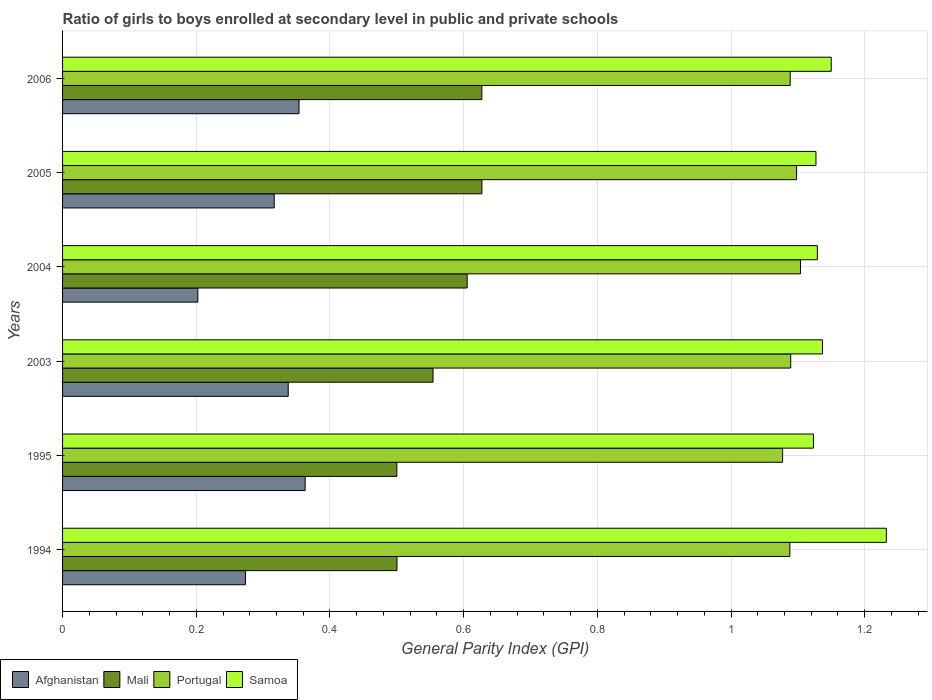How many groups of bars are there?
Your answer should be very brief. 6. Are the number of bars per tick equal to the number of legend labels?
Offer a very short reply. Yes. Are the number of bars on each tick of the Y-axis equal?
Offer a very short reply. Yes. How many bars are there on the 5th tick from the bottom?
Ensure brevity in your answer.  4. What is the general parity index in Mali in 2004?
Your answer should be compact. 0.61. Across all years, what is the maximum general parity index in Portugal?
Offer a very short reply. 1.1. Across all years, what is the minimum general parity index in Mali?
Provide a short and direct response. 0.5. What is the total general parity index in Afghanistan in the graph?
Provide a short and direct response. 1.85. What is the difference between the general parity index in Portugal in 1994 and that in 2003?
Provide a succinct answer. -0. What is the difference between the general parity index in Samoa in 2006 and the general parity index in Portugal in 1995?
Ensure brevity in your answer.  0.07. What is the average general parity index in Samoa per year?
Ensure brevity in your answer.  1.15. In the year 1995, what is the difference between the general parity index in Samoa and general parity index in Afghanistan?
Your answer should be very brief. 0.76. In how many years, is the general parity index in Mali greater than 0.8 ?
Offer a terse response. 0. What is the ratio of the general parity index in Afghanistan in 1995 to that in 2005?
Make the answer very short. 1.15. Is the general parity index in Samoa in 1995 less than that in 2003?
Give a very brief answer. Yes. Is the difference between the general parity index in Samoa in 2003 and 2005 greater than the difference between the general parity index in Afghanistan in 2003 and 2005?
Provide a succinct answer. No. What is the difference between the highest and the second highest general parity index in Portugal?
Give a very brief answer. 0.01. What is the difference between the highest and the lowest general parity index in Afghanistan?
Provide a short and direct response. 0.16. In how many years, is the general parity index in Samoa greater than the average general parity index in Samoa taken over all years?
Provide a short and direct response. 2. Is the sum of the general parity index in Portugal in 2005 and 2006 greater than the maximum general parity index in Mali across all years?
Your answer should be compact. Yes. What does the 3rd bar from the top in 2005 represents?
Give a very brief answer. Mali. What does the 2nd bar from the bottom in 1995 represents?
Your response must be concise. Mali. Is it the case that in every year, the sum of the general parity index in Mali and general parity index in Afghanistan is greater than the general parity index in Samoa?
Offer a terse response. No. How many bars are there?
Offer a very short reply. 24. Are all the bars in the graph horizontal?
Ensure brevity in your answer.  Yes. How many years are there in the graph?
Provide a succinct answer. 6. What is the difference between two consecutive major ticks on the X-axis?
Your answer should be compact. 0.2. Where does the legend appear in the graph?
Ensure brevity in your answer.  Bottom left. How are the legend labels stacked?
Make the answer very short. Horizontal. What is the title of the graph?
Give a very brief answer. Ratio of girls to boys enrolled at secondary level in public and private schools. Does "Mauritania" appear as one of the legend labels in the graph?
Offer a very short reply. No. What is the label or title of the X-axis?
Offer a terse response. General Parity Index (GPI). What is the General Parity Index (GPI) in Afghanistan in 1994?
Keep it short and to the point. 0.27. What is the General Parity Index (GPI) in Mali in 1994?
Ensure brevity in your answer.  0.5. What is the General Parity Index (GPI) of Portugal in 1994?
Your answer should be compact. 1.09. What is the General Parity Index (GPI) in Samoa in 1994?
Offer a terse response. 1.23. What is the General Parity Index (GPI) in Afghanistan in 1995?
Keep it short and to the point. 0.36. What is the General Parity Index (GPI) of Mali in 1995?
Give a very brief answer. 0.5. What is the General Parity Index (GPI) in Portugal in 1995?
Provide a short and direct response. 1.08. What is the General Parity Index (GPI) in Samoa in 1995?
Provide a short and direct response. 1.12. What is the General Parity Index (GPI) of Afghanistan in 2003?
Ensure brevity in your answer.  0.34. What is the General Parity Index (GPI) in Mali in 2003?
Provide a succinct answer. 0.55. What is the General Parity Index (GPI) of Portugal in 2003?
Give a very brief answer. 1.09. What is the General Parity Index (GPI) of Samoa in 2003?
Provide a succinct answer. 1.14. What is the General Parity Index (GPI) in Afghanistan in 2004?
Your answer should be very brief. 0.2. What is the General Parity Index (GPI) of Mali in 2004?
Offer a terse response. 0.61. What is the General Parity Index (GPI) in Portugal in 2004?
Offer a very short reply. 1.1. What is the General Parity Index (GPI) of Samoa in 2004?
Make the answer very short. 1.13. What is the General Parity Index (GPI) of Afghanistan in 2005?
Give a very brief answer. 0.32. What is the General Parity Index (GPI) of Mali in 2005?
Provide a short and direct response. 0.63. What is the General Parity Index (GPI) of Portugal in 2005?
Make the answer very short. 1.1. What is the General Parity Index (GPI) in Samoa in 2005?
Offer a terse response. 1.13. What is the General Parity Index (GPI) in Afghanistan in 2006?
Give a very brief answer. 0.35. What is the General Parity Index (GPI) of Mali in 2006?
Your response must be concise. 0.63. What is the General Parity Index (GPI) in Portugal in 2006?
Your response must be concise. 1.09. What is the General Parity Index (GPI) of Samoa in 2006?
Your answer should be compact. 1.15. Across all years, what is the maximum General Parity Index (GPI) in Afghanistan?
Ensure brevity in your answer.  0.36. Across all years, what is the maximum General Parity Index (GPI) of Mali?
Offer a terse response. 0.63. Across all years, what is the maximum General Parity Index (GPI) in Portugal?
Offer a terse response. 1.1. Across all years, what is the maximum General Parity Index (GPI) in Samoa?
Ensure brevity in your answer.  1.23. Across all years, what is the minimum General Parity Index (GPI) of Afghanistan?
Your answer should be very brief. 0.2. Across all years, what is the minimum General Parity Index (GPI) in Mali?
Your response must be concise. 0.5. Across all years, what is the minimum General Parity Index (GPI) in Portugal?
Provide a succinct answer. 1.08. Across all years, what is the minimum General Parity Index (GPI) in Samoa?
Provide a short and direct response. 1.12. What is the total General Parity Index (GPI) in Afghanistan in the graph?
Your answer should be very brief. 1.85. What is the total General Parity Index (GPI) of Mali in the graph?
Offer a very short reply. 3.41. What is the total General Parity Index (GPI) in Portugal in the graph?
Offer a very short reply. 6.55. What is the total General Parity Index (GPI) of Samoa in the graph?
Your answer should be compact. 6.9. What is the difference between the General Parity Index (GPI) in Afghanistan in 1994 and that in 1995?
Your response must be concise. -0.09. What is the difference between the General Parity Index (GPI) in Portugal in 1994 and that in 1995?
Your answer should be compact. 0.01. What is the difference between the General Parity Index (GPI) in Samoa in 1994 and that in 1995?
Your answer should be compact. 0.11. What is the difference between the General Parity Index (GPI) of Afghanistan in 1994 and that in 2003?
Your answer should be very brief. -0.06. What is the difference between the General Parity Index (GPI) in Mali in 1994 and that in 2003?
Your answer should be very brief. -0.05. What is the difference between the General Parity Index (GPI) in Portugal in 1994 and that in 2003?
Your answer should be compact. -0. What is the difference between the General Parity Index (GPI) of Samoa in 1994 and that in 2003?
Make the answer very short. 0.1. What is the difference between the General Parity Index (GPI) in Afghanistan in 1994 and that in 2004?
Make the answer very short. 0.07. What is the difference between the General Parity Index (GPI) of Mali in 1994 and that in 2004?
Your response must be concise. -0.1. What is the difference between the General Parity Index (GPI) in Portugal in 1994 and that in 2004?
Offer a very short reply. -0.02. What is the difference between the General Parity Index (GPI) of Samoa in 1994 and that in 2004?
Make the answer very short. 0.1. What is the difference between the General Parity Index (GPI) of Afghanistan in 1994 and that in 2005?
Keep it short and to the point. -0.04. What is the difference between the General Parity Index (GPI) of Mali in 1994 and that in 2005?
Your answer should be very brief. -0.13. What is the difference between the General Parity Index (GPI) of Portugal in 1994 and that in 2005?
Your answer should be very brief. -0.01. What is the difference between the General Parity Index (GPI) of Samoa in 1994 and that in 2005?
Ensure brevity in your answer.  0.11. What is the difference between the General Parity Index (GPI) of Afghanistan in 1994 and that in 2006?
Provide a succinct answer. -0.08. What is the difference between the General Parity Index (GPI) of Mali in 1994 and that in 2006?
Your response must be concise. -0.13. What is the difference between the General Parity Index (GPI) in Portugal in 1994 and that in 2006?
Your response must be concise. -0. What is the difference between the General Parity Index (GPI) of Samoa in 1994 and that in 2006?
Provide a short and direct response. 0.08. What is the difference between the General Parity Index (GPI) of Afghanistan in 1995 and that in 2003?
Offer a very short reply. 0.03. What is the difference between the General Parity Index (GPI) in Mali in 1995 and that in 2003?
Provide a succinct answer. -0.05. What is the difference between the General Parity Index (GPI) in Portugal in 1995 and that in 2003?
Provide a succinct answer. -0.01. What is the difference between the General Parity Index (GPI) in Samoa in 1995 and that in 2003?
Your response must be concise. -0.01. What is the difference between the General Parity Index (GPI) of Afghanistan in 1995 and that in 2004?
Make the answer very short. 0.16. What is the difference between the General Parity Index (GPI) of Mali in 1995 and that in 2004?
Provide a succinct answer. -0.11. What is the difference between the General Parity Index (GPI) of Portugal in 1995 and that in 2004?
Ensure brevity in your answer.  -0.03. What is the difference between the General Parity Index (GPI) of Samoa in 1995 and that in 2004?
Give a very brief answer. -0.01. What is the difference between the General Parity Index (GPI) in Afghanistan in 1995 and that in 2005?
Make the answer very short. 0.05. What is the difference between the General Parity Index (GPI) in Mali in 1995 and that in 2005?
Your answer should be very brief. -0.13. What is the difference between the General Parity Index (GPI) of Portugal in 1995 and that in 2005?
Your answer should be very brief. -0.02. What is the difference between the General Parity Index (GPI) of Samoa in 1995 and that in 2005?
Your answer should be compact. -0. What is the difference between the General Parity Index (GPI) of Afghanistan in 1995 and that in 2006?
Make the answer very short. 0.01. What is the difference between the General Parity Index (GPI) in Mali in 1995 and that in 2006?
Give a very brief answer. -0.13. What is the difference between the General Parity Index (GPI) in Portugal in 1995 and that in 2006?
Keep it short and to the point. -0.01. What is the difference between the General Parity Index (GPI) in Samoa in 1995 and that in 2006?
Provide a succinct answer. -0.03. What is the difference between the General Parity Index (GPI) in Afghanistan in 2003 and that in 2004?
Keep it short and to the point. 0.14. What is the difference between the General Parity Index (GPI) of Mali in 2003 and that in 2004?
Provide a short and direct response. -0.05. What is the difference between the General Parity Index (GPI) of Portugal in 2003 and that in 2004?
Keep it short and to the point. -0.01. What is the difference between the General Parity Index (GPI) of Samoa in 2003 and that in 2004?
Offer a very short reply. 0.01. What is the difference between the General Parity Index (GPI) of Afghanistan in 2003 and that in 2005?
Provide a succinct answer. 0.02. What is the difference between the General Parity Index (GPI) of Mali in 2003 and that in 2005?
Make the answer very short. -0.07. What is the difference between the General Parity Index (GPI) in Portugal in 2003 and that in 2005?
Keep it short and to the point. -0.01. What is the difference between the General Parity Index (GPI) in Samoa in 2003 and that in 2005?
Provide a succinct answer. 0.01. What is the difference between the General Parity Index (GPI) in Afghanistan in 2003 and that in 2006?
Your answer should be compact. -0.02. What is the difference between the General Parity Index (GPI) of Mali in 2003 and that in 2006?
Provide a short and direct response. -0.07. What is the difference between the General Parity Index (GPI) in Portugal in 2003 and that in 2006?
Keep it short and to the point. 0. What is the difference between the General Parity Index (GPI) of Samoa in 2003 and that in 2006?
Your response must be concise. -0.01. What is the difference between the General Parity Index (GPI) in Afghanistan in 2004 and that in 2005?
Your answer should be compact. -0.11. What is the difference between the General Parity Index (GPI) of Mali in 2004 and that in 2005?
Offer a terse response. -0.02. What is the difference between the General Parity Index (GPI) in Portugal in 2004 and that in 2005?
Your response must be concise. 0.01. What is the difference between the General Parity Index (GPI) of Samoa in 2004 and that in 2005?
Keep it short and to the point. 0. What is the difference between the General Parity Index (GPI) in Afghanistan in 2004 and that in 2006?
Give a very brief answer. -0.15. What is the difference between the General Parity Index (GPI) of Mali in 2004 and that in 2006?
Offer a very short reply. -0.02. What is the difference between the General Parity Index (GPI) in Portugal in 2004 and that in 2006?
Your response must be concise. 0.02. What is the difference between the General Parity Index (GPI) in Samoa in 2004 and that in 2006?
Your answer should be compact. -0.02. What is the difference between the General Parity Index (GPI) of Afghanistan in 2005 and that in 2006?
Your answer should be very brief. -0.04. What is the difference between the General Parity Index (GPI) in Portugal in 2005 and that in 2006?
Keep it short and to the point. 0.01. What is the difference between the General Parity Index (GPI) of Samoa in 2005 and that in 2006?
Give a very brief answer. -0.02. What is the difference between the General Parity Index (GPI) in Afghanistan in 1994 and the General Parity Index (GPI) in Mali in 1995?
Provide a short and direct response. -0.23. What is the difference between the General Parity Index (GPI) of Afghanistan in 1994 and the General Parity Index (GPI) of Portugal in 1995?
Keep it short and to the point. -0.8. What is the difference between the General Parity Index (GPI) in Afghanistan in 1994 and the General Parity Index (GPI) in Samoa in 1995?
Provide a succinct answer. -0.85. What is the difference between the General Parity Index (GPI) in Mali in 1994 and the General Parity Index (GPI) in Portugal in 1995?
Offer a terse response. -0.58. What is the difference between the General Parity Index (GPI) of Mali in 1994 and the General Parity Index (GPI) of Samoa in 1995?
Your answer should be compact. -0.62. What is the difference between the General Parity Index (GPI) in Portugal in 1994 and the General Parity Index (GPI) in Samoa in 1995?
Offer a very short reply. -0.04. What is the difference between the General Parity Index (GPI) in Afghanistan in 1994 and the General Parity Index (GPI) in Mali in 2003?
Provide a short and direct response. -0.28. What is the difference between the General Parity Index (GPI) in Afghanistan in 1994 and the General Parity Index (GPI) in Portugal in 2003?
Provide a short and direct response. -0.82. What is the difference between the General Parity Index (GPI) of Afghanistan in 1994 and the General Parity Index (GPI) of Samoa in 2003?
Make the answer very short. -0.86. What is the difference between the General Parity Index (GPI) in Mali in 1994 and the General Parity Index (GPI) in Portugal in 2003?
Make the answer very short. -0.59. What is the difference between the General Parity Index (GPI) of Mali in 1994 and the General Parity Index (GPI) of Samoa in 2003?
Provide a succinct answer. -0.64. What is the difference between the General Parity Index (GPI) of Portugal in 1994 and the General Parity Index (GPI) of Samoa in 2003?
Provide a short and direct response. -0.05. What is the difference between the General Parity Index (GPI) of Afghanistan in 1994 and the General Parity Index (GPI) of Mali in 2004?
Your response must be concise. -0.33. What is the difference between the General Parity Index (GPI) of Afghanistan in 1994 and the General Parity Index (GPI) of Portugal in 2004?
Give a very brief answer. -0.83. What is the difference between the General Parity Index (GPI) in Afghanistan in 1994 and the General Parity Index (GPI) in Samoa in 2004?
Your response must be concise. -0.86. What is the difference between the General Parity Index (GPI) in Mali in 1994 and the General Parity Index (GPI) in Portugal in 2004?
Your response must be concise. -0.6. What is the difference between the General Parity Index (GPI) in Mali in 1994 and the General Parity Index (GPI) in Samoa in 2004?
Your answer should be very brief. -0.63. What is the difference between the General Parity Index (GPI) in Portugal in 1994 and the General Parity Index (GPI) in Samoa in 2004?
Offer a terse response. -0.04. What is the difference between the General Parity Index (GPI) in Afghanistan in 1994 and the General Parity Index (GPI) in Mali in 2005?
Ensure brevity in your answer.  -0.35. What is the difference between the General Parity Index (GPI) of Afghanistan in 1994 and the General Parity Index (GPI) of Portugal in 2005?
Your response must be concise. -0.82. What is the difference between the General Parity Index (GPI) in Afghanistan in 1994 and the General Parity Index (GPI) in Samoa in 2005?
Provide a succinct answer. -0.85. What is the difference between the General Parity Index (GPI) in Mali in 1994 and the General Parity Index (GPI) in Portugal in 2005?
Make the answer very short. -0.6. What is the difference between the General Parity Index (GPI) of Mali in 1994 and the General Parity Index (GPI) of Samoa in 2005?
Offer a very short reply. -0.63. What is the difference between the General Parity Index (GPI) of Portugal in 1994 and the General Parity Index (GPI) of Samoa in 2005?
Your answer should be very brief. -0.04. What is the difference between the General Parity Index (GPI) of Afghanistan in 1994 and the General Parity Index (GPI) of Mali in 2006?
Your answer should be very brief. -0.35. What is the difference between the General Parity Index (GPI) in Afghanistan in 1994 and the General Parity Index (GPI) in Portugal in 2006?
Offer a very short reply. -0.81. What is the difference between the General Parity Index (GPI) in Afghanistan in 1994 and the General Parity Index (GPI) in Samoa in 2006?
Your response must be concise. -0.88. What is the difference between the General Parity Index (GPI) of Mali in 1994 and the General Parity Index (GPI) of Portugal in 2006?
Your answer should be very brief. -0.59. What is the difference between the General Parity Index (GPI) of Mali in 1994 and the General Parity Index (GPI) of Samoa in 2006?
Offer a terse response. -0.65. What is the difference between the General Parity Index (GPI) of Portugal in 1994 and the General Parity Index (GPI) of Samoa in 2006?
Provide a short and direct response. -0.06. What is the difference between the General Parity Index (GPI) in Afghanistan in 1995 and the General Parity Index (GPI) in Mali in 2003?
Offer a terse response. -0.19. What is the difference between the General Parity Index (GPI) in Afghanistan in 1995 and the General Parity Index (GPI) in Portugal in 2003?
Provide a short and direct response. -0.73. What is the difference between the General Parity Index (GPI) in Afghanistan in 1995 and the General Parity Index (GPI) in Samoa in 2003?
Offer a very short reply. -0.77. What is the difference between the General Parity Index (GPI) in Mali in 1995 and the General Parity Index (GPI) in Portugal in 2003?
Your answer should be very brief. -0.59. What is the difference between the General Parity Index (GPI) in Mali in 1995 and the General Parity Index (GPI) in Samoa in 2003?
Provide a succinct answer. -0.64. What is the difference between the General Parity Index (GPI) in Portugal in 1995 and the General Parity Index (GPI) in Samoa in 2003?
Provide a short and direct response. -0.06. What is the difference between the General Parity Index (GPI) in Afghanistan in 1995 and the General Parity Index (GPI) in Mali in 2004?
Ensure brevity in your answer.  -0.24. What is the difference between the General Parity Index (GPI) of Afghanistan in 1995 and the General Parity Index (GPI) of Portugal in 2004?
Keep it short and to the point. -0.74. What is the difference between the General Parity Index (GPI) in Afghanistan in 1995 and the General Parity Index (GPI) in Samoa in 2004?
Keep it short and to the point. -0.77. What is the difference between the General Parity Index (GPI) of Mali in 1995 and the General Parity Index (GPI) of Portugal in 2004?
Provide a succinct answer. -0.6. What is the difference between the General Parity Index (GPI) in Mali in 1995 and the General Parity Index (GPI) in Samoa in 2004?
Offer a terse response. -0.63. What is the difference between the General Parity Index (GPI) in Portugal in 1995 and the General Parity Index (GPI) in Samoa in 2004?
Provide a short and direct response. -0.05. What is the difference between the General Parity Index (GPI) in Afghanistan in 1995 and the General Parity Index (GPI) in Mali in 2005?
Keep it short and to the point. -0.26. What is the difference between the General Parity Index (GPI) of Afghanistan in 1995 and the General Parity Index (GPI) of Portugal in 2005?
Provide a succinct answer. -0.74. What is the difference between the General Parity Index (GPI) of Afghanistan in 1995 and the General Parity Index (GPI) of Samoa in 2005?
Keep it short and to the point. -0.76. What is the difference between the General Parity Index (GPI) in Mali in 1995 and the General Parity Index (GPI) in Portugal in 2005?
Provide a succinct answer. -0.6. What is the difference between the General Parity Index (GPI) of Mali in 1995 and the General Parity Index (GPI) of Samoa in 2005?
Your response must be concise. -0.63. What is the difference between the General Parity Index (GPI) in Portugal in 1995 and the General Parity Index (GPI) in Samoa in 2005?
Your answer should be compact. -0.05. What is the difference between the General Parity Index (GPI) in Afghanistan in 1995 and the General Parity Index (GPI) in Mali in 2006?
Offer a very short reply. -0.26. What is the difference between the General Parity Index (GPI) of Afghanistan in 1995 and the General Parity Index (GPI) of Portugal in 2006?
Offer a terse response. -0.73. What is the difference between the General Parity Index (GPI) in Afghanistan in 1995 and the General Parity Index (GPI) in Samoa in 2006?
Your answer should be very brief. -0.79. What is the difference between the General Parity Index (GPI) of Mali in 1995 and the General Parity Index (GPI) of Portugal in 2006?
Offer a terse response. -0.59. What is the difference between the General Parity Index (GPI) in Mali in 1995 and the General Parity Index (GPI) in Samoa in 2006?
Your answer should be compact. -0.65. What is the difference between the General Parity Index (GPI) in Portugal in 1995 and the General Parity Index (GPI) in Samoa in 2006?
Keep it short and to the point. -0.07. What is the difference between the General Parity Index (GPI) of Afghanistan in 2003 and the General Parity Index (GPI) of Mali in 2004?
Provide a short and direct response. -0.27. What is the difference between the General Parity Index (GPI) in Afghanistan in 2003 and the General Parity Index (GPI) in Portugal in 2004?
Your answer should be very brief. -0.77. What is the difference between the General Parity Index (GPI) of Afghanistan in 2003 and the General Parity Index (GPI) of Samoa in 2004?
Ensure brevity in your answer.  -0.79. What is the difference between the General Parity Index (GPI) in Mali in 2003 and the General Parity Index (GPI) in Portugal in 2004?
Make the answer very short. -0.55. What is the difference between the General Parity Index (GPI) in Mali in 2003 and the General Parity Index (GPI) in Samoa in 2004?
Provide a succinct answer. -0.57. What is the difference between the General Parity Index (GPI) of Portugal in 2003 and the General Parity Index (GPI) of Samoa in 2004?
Ensure brevity in your answer.  -0.04. What is the difference between the General Parity Index (GPI) of Afghanistan in 2003 and the General Parity Index (GPI) of Mali in 2005?
Your answer should be very brief. -0.29. What is the difference between the General Parity Index (GPI) of Afghanistan in 2003 and the General Parity Index (GPI) of Portugal in 2005?
Keep it short and to the point. -0.76. What is the difference between the General Parity Index (GPI) in Afghanistan in 2003 and the General Parity Index (GPI) in Samoa in 2005?
Provide a succinct answer. -0.79. What is the difference between the General Parity Index (GPI) of Mali in 2003 and the General Parity Index (GPI) of Portugal in 2005?
Offer a terse response. -0.54. What is the difference between the General Parity Index (GPI) in Mali in 2003 and the General Parity Index (GPI) in Samoa in 2005?
Your answer should be compact. -0.57. What is the difference between the General Parity Index (GPI) in Portugal in 2003 and the General Parity Index (GPI) in Samoa in 2005?
Offer a very short reply. -0.04. What is the difference between the General Parity Index (GPI) of Afghanistan in 2003 and the General Parity Index (GPI) of Mali in 2006?
Your response must be concise. -0.29. What is the difference between the General Parity Index (GPI) in Afghanistan in 2003 and the General Parity Index (GPI) in Portugal in 2006?
Ensure brevity in your answer.  -0.75. What is the difference between the General Parity Index (GPI) in Afghanistan in 2003 and the General Parity Index (GPI) in Samoa in 2006?
Ensure brevity in your answer.  -0.81. What is the difference between the General Parity Index (GPI) of Mali in 2003 and the General Parity Index (GPI) of Portugal in 2006?
Give a very brief answer. -0.53. What is the difference between the General Parity Index (GPI) in Mali in 2003 and the General Parity Index (GPI) in Samoa in 2006?
Provide a succinct answer. -0.6. What is the difference between the General Parity Index (GPI) in Portugal in 2003 and the General Parity Index (GPI) in Samoa in 2006?
Your answer should be very brief. -0.06. What is the difference between the General Parity Index (GPI) in Afghanistan in 2004 and the General Parity Index (GPI) in Mali in 2005?
Give a very brief answer. -0.42. What is the difference between the General Parity Index (GPI) of Afghanistan in 2004 and the General Parity Index (GPI) of Portugal in 2005?
Your answer should be compact. -0.9. What is the difference between the General Parity Index (GPI) of Afghanistan in 2004 and the General Parity Index (GPI) of Samoa in 2005?
Your answer should be compact. -0.92. What is the difference between the General Parity Index (GPI) of Mali in 2004 and the General Parity Index (GPI) of Portugal in 2005?
Provide a succinct answer. -0.49. What is the difference between the General Parity Index (GPI) in Mali in 2004 and the General Parity Index (GPI) in Samoa in 2005?
Give a very brief answer. -0.52. What is the difference between the General Parity Index (GPI) in Portugal in 2004 and the General Parity Index (GPI) in Samoa in 2005?
Ensure brevity in your answer.  -0.02. What is the difference between the General Parity Index (GPI) of Afghanistan in 2004 and the General Parity Index (GPI) of Mali in 2006?
Make the answer very short. -0.42. What is the difference between the General Parity Index (GPI) in Afghanistan in 2004 and the General Parity Index (GPI) in Portugal in 2006?
Ensure brevity in your answer.  -0.89. What is the difference between the General Parity Index (GPI) of Afghanistan in 2004 and the General Parity Index (GPI) of Samoa in 2006?
Provide a succinct answer. -0.95. What is the difference between the General Parity Index (GPI) in Mali in 2004 and the General Parity Index (GPI) in Portugal in 2006?
Provide a succinct answer. -0.48. What is the difference between the General Parity Index (GPI) of Mali in 2004 and the General Parity Index (GPI) of Samoa in 2006?
Your response must be concise. -0.54. What is the difference between the General Parity Index (GPI) of Portugal in 2004 and the General Parity Index (GPI) of Samoa in 2006?
Offer a very short reply. -0.05. What is the difference between the General Parity Index (GPI) in Afghanistan in 2005 and the General Parity Index (GPI) in Mali in 2006?
Provide a short and direct response. -0.31. What is the difference between the General Parity Index (GPI) in Afghanistan in 2005 and the General Parity Index (GPI) in Portugal in 2006?
Your response must be concise. -0.77. What is the difference between the General Parity Index (GPI) in Mali in 2005 and the General Parity Index (GPI) in Portugal in 2006?
Provide a succinct answer. -0.46. What is the difference between the General Parity Index (GPI) of Mali in 2005 and the General Parity Index (GPI) of Samoa in 2006?
Your response must be concise. -0.52. What is the difference between the General Parity Index (GPI) of Portugal in 2005 and the General Parity Index (GPI) of Samoa in 2006?
Offer a very short reply. -0.05. What is the average General Parity Index (GPI) in Afghanistan per year?
Offer a very short reply. 0.31. What is the average General Parity Index (GPI) of Mali per year?
Your answer should be compact. 0.57. What is the average General Parity Index (GPI) of Samoa per year?
Ensure brevity in your answer.  1.15. In the year 1994, what is the difference between the General Parity Index (GPI) in Afghanistan and General Parity Index (GPI) in Mali?
Make the answer very short. -0.23. In the year 1994, what is the difference between the General Parity Index (GPI) of Afghanistan and General Parity Index (GPI) of Portugal?
Offer a very short reply. -0.81. In the year 1994, what is the difference between the General Parity Index (GPI) in Afghanistan and General Parity Index (GPI) in Samoa?
Your response must be concise. -0.96. In the year 1994, what is the difference between the General Parity Index (GPI) of Mali and General Parity Index (GPI) of Portugal?
Keep it short and to the point. -0.59. In the year 1994, what is the difference between the General Parity Index (GPI) of Mali and General Parity Index (GPI) of Samoa?
Your answer should be very brief. -0.73. In the year 1994, what is the difference between the General Parity Index (GPI) of Portugal and General Parity Index (GPI) of Samoa?
Give a very brief answer. -0.14. In the year 1995, what is the difference between the General Parity Index (GPI) in Afghanistan and General Parity Index (GPI) in Mali?
Offer a very short reply. -0.14. In the year 1995, what is the difference between the General Parity Index (GPI) in Afghanistan and General Parity Index (GPI) in Portugal?
Provide a succinct answer. -0.71. In the year 1995, what is the difference between the General Parity Index (GPI) of Afghanistan and General Parity Index (GPI) of Samoa?
Your answer should be compact. -0.76. In the year 1995, what is the difference between the General Parity Index (GPI) of Mali and General Parity Index (GPI) of Portugal?
Your answer should be very brief. -0.58. In the year 1995, what is the difference between the General Parity Index (GPI) in Mali and General Parity Index (GPI) in Samoa?
Offer a very short reply. -0.62. In the year 1995, what is the difference between the General Parity Index (GPI) of Portugal and General Parity Index (GPI) of Samoa?
Keep it short and to the point. -0.05. In the year 2003, what is the difference between the General Parity Index (GPI) of Afghanistan and General Parity Index (GPI) of Mali?
Your answer should be compact. -0.22. In the year 2003, what is the difference between the General Parity Index (GPI) in Afghanistan and General Parity Index (GPI) in Portugal?
Give a very brief answer. -0.75. In the year 2003, what is the difference between the General Parity Index (GPI) in Afghanistan and General Parity Index (GPI) in Samoa?
Provide a short and direct response. -0.8. In the year 2003, what is the difference between the General Parity Index (GPI) of Mali and General Parity Index (GPI) of Portugal?
Your response must be concise. -0.54. In the year 2003, what is the difference between the General Parity Index (GPI) in Mali and General Parity Index (GPI) in Samoa?
Your response must be concise. -0.58. In the year 2003, what is the difference between the General Parity Index (GPI) of Portugal and General Parity Index (GPI) of Samoa?
Make the answer very short. -0.05. In the year 2004, what is the difference between the General Parity Index (GPI) in Afghanistan and General Parity Index (GPI) in Mali?
Provide a succinct answer. -0.4. In the year 2004, what is the difference between the General Parity Index (GPI) in Afghanistan and General Parity Index (GPI) in Portugal?
Provide a short and direct response. -0.9. In the year 2004, what is the difference between the General Parity Index (GPI) of Afghanistan and General Parity Index (GPI) of Samoa?
Offer a very short reply. -0.93. In the year 2004, what is the difference between the General Parity Index (GPI) of Mali and General Parity Index (GPI) of Portugal?
Ensure brevity in your answer.  -0.5. In the year 2004, what is the difference between the General Parity Index (GPI) of Mali and General Parity Index (GPI) of Samoa?
Your answer should be very brief. -0.52. In the year 2004, what is the difference between the General Parity Index (GPI) in Portugal and General Parity Index (GPI) in Samoa?
Your answer should be compact. -0.03. In the year 2005, what is the difference between the General Parity Index (GPI) in Afghanistan and General Parity Index (GPI) in Mali?
Provide a succinct answer. -0.31. In the year 2005, what is the difference between the General Parity Index (GPI) of Afghanistan and General Parity Index (GPI) of Portugal?
Give a very brief answer. -0.78. In the year 2005, what is the difference between the General Parity Index (GPI) in Afghanistan and General Parity Index (GPI) in Samoa?
Your answer should be compact. -0.81. In the year 2005, what is the difference between the General Parity Index (GPI) of Mali and General Parity Index (GPI) of Portugal?
Offer a very short reply. -0.47. In the year 2005, what is the difference between the General Parity Index (GPI) in Mali and General Parity Index (GPI) in Samoa?
Your answer should be very brief. -0.5. In the year 2005, what is the difference between the General Parity Index (GPI) in Portugal and General Parity Index (GPI) in Samoa?
Provide a short and direct response. -0.03. In the year 2006, what is the difference between the General Parity Index (GPI) in Afghanistan and General Parity Index (GPI) in Mali?
Your response must be concise. -0.27. In the year 2006, what is the difference between the General Parity Index (GPI) in Afghanistan and General Parity Index (GPI) in Portugal?
Offer a terse response. -0.73. In the year 2006, what is the difference between the General Parity Index (GPI) in Afghanistan and General Parity Index (GPI) in Samoa?
Provide a short and direct response. -0.8. In the year 2006, what is the difference between the General Parity Index (GPI) in Mali and General Parity Index (GPI) in Portugal?
Your answer should be very brief. -0.46. In the year 2006, what is the difference between the General Parity Index (GPI) of Mali and General Parity Index (GPI) of Samoa?
Provide a short and direct response. -0.52. In the year 2006, what is the difference between the General Parity Index (GPI) of Portugal and General Parity Index (GPI) of Samoa?
Give a very brief answer. -0.06. What is the ratio of the General Parity Index (GPI) in Afghanistan in 1994 to that in 1995?
Give a very brief answer. 0.75. What is the ratio of the General Parity Index (GPI) in Mali in 1994 to that in 1995?
Offer a terse response. 1. What is the ratio of the General Parity Index (GPI) in Samoa in 1994 to that in 1995?
Offer a very short reply. 1.1. What is the ratio of the General Parity Index (GPI) of Afghanistan in 1994 to that in 2003?
Your response must be concise. 0.81. What is the ratio of the General Parity Index (GPI) of Mali in 1994 to that in 2003?
Your response must be concise. 0.9. What is the ratio of the General Parity Index (GPI) in Portugal in 1994 to that in 2003?
Give a very brief answer. 1. What is the ratio of the General Parity Index (GPI) in Samoa in 1994 to that in 2003?
Make the answer very short. 1.08. What is the ratio of the General Parity Index (GPI) in Afghanistan in 1994 to that in 2004?
Ensure brevity in your answer.  1.35. What is the ratio of the General Parity Index (GPI) in Mali in 1994 to that in 2004?
Provide a short and direct response. 0.83. What is the ratio of the General Parity Index (GPI) of Portugal in 1994 to that in 2004?
Give a very brief answer. 0.99. What is the ratio of the General Parity Index (GPI) in Samoa in 1994 to that in 2004?
Give a very brief answer. 1.09. What is the ratio of the General Parity Index (GPI) of Afghanistan in 1994 to that in 2005?
Your answer should be compact. 0.86. What is the ratio of the General Parity Index (GPI) in Mali in 1994 to that in 2005?
Offer a terse response. 0.8. What is the ratio of the General Parity Index (GPI) in Portugal in 1994 to that in 2005?
Your response must be concise. 0.99. What is the ratio of the General Parity Index (GPI) of Samoa in 1994 to that in 2005?
Offer a very short reply. 1.09. What is the ratio of the General Parity Index (GPI) in Afghanistan in 1994 to that in 2006?
Provide a succinct answer. 0.77. What is the ratio of the General Parity Index (GPI) in Mali in 1994 to that in 2006?
Your response must be concise. 0.8. What is the ratio of the General Parity Index (GPI) in Samoa in 1994 to that in 2006?
Keep it short and to the point. 1.07. What is the ratio of the General Parity Index (GPI) of Afghanistan in 1995 to that in 2003?
Make the answer very short. 1.07. What is the ratio of the General Parity Index (GPI) of Mali in 1995 to that in 2003?
Provide a succinct answer. 0.9. What is the ratio of the General Parity Index (GPI) of Portugal in 1995 to that in 2003?
Give a very brief answer. 0.99. What is the ratio of the General Parity Index (GPI) in Afghanistan in 1995 to that in 2004?
Offer a terse response. 1.79. What is the ratio of the General Parity Index (GPI) of Mali in 1995 to that in 2004?
Provide a short and direct response. 0.83. What is the ratio of the General Parity Index (GPI) in Portugal in 1995 to that in 2004?
Provide a succinct answer. 0.98. What is the ratio of the General Parity Index (GPI) in Samoa in 1995 to that in 2004?
Offer a terse response. 0.99. What is the ratio of the General Parity Index (GPI) in Afghanistan in 1995 to that in 2005?
Give a very brief answer. 1.15. What is the ratio of the General Parity Index (GPI) of Mali in 1995 to that in 2005?
Provide a succinct answer. 0.8. What is the ratio of the General Parity Index (GPI) of Portugal in 1995 to that in 2005?
Your answer should be compact. 0.98. What is the ratio of the General Parity Index (GPI) of Samoa in 1995 to that in 2005?
Provide a succinct answer. 1. What is the ratio of the General Parity Index (GPI) of Afghanistan in 1995 to that in 2006?
Give a very brief answer. 1.03. What is the ratio of the General Parity Index (GPI) of Mali in 1995 to that in 2006?
Your response must be concise. 0.8. What is the ratio of the General Parity Index (GPI) of Portugal in 1995 to that in 2006?
Keep it short and to the point. 0.99. What is the ratio of the General Parity Index (GPI) in Samoa in 1995 to that in 2006?
Your answer should be very brief. 0.98. What is the ratio of the General Parity Index (GPI) of Afghanistan in 2003 to that in 2004?
Your response must be concise. 1.67. What is the ratio of the General Parity Index (GPI) of Mali in 2003 to that in 2004?
Make the answer very short. 0.92. What is the ratio of the General Parity Index (GPI) in Portugal in 2003 to that in 2004?
Ensure brevity in your answer.  0.99. What is the ratio of the General Parity Index (GPI) of Samoa in 2003 to that in 2004?
Your answer should be very brief. 1.01. What is the ratio of the General Parity Index (GPI) in Afghanistan in 2003 to that in 2005?
Offer a terse response. 1.07. What is the ratio of the General Parity Index (GPI) in Mali in 2003 to that in 2005?
Offer a terse response. 0.88. What is the ratio of the General Parity Index (GPI) in Samoa in 2003 to that in 2005?
Your answer should be very brief. 1.01. What is the ratio of the General Parity Index (GPI) in Afghanistan in 2003 to that in 2006?
Provide a short and direct response. 0.95. What is the ratio of the General Parity Index (GPI) in Mali in 2003 to that in 2006?
Ensure brevity in your answer.  0.88. What is the ratio of the General Parity Index (GPI) of Samoa in 2003 to that in 2006?
Give a very brief answer. 0.99. What is the ratio of the General Parity Index (GPI) of Afghanistan in 2004 to that in 2005?
Provide a succinct answer. 0.64. What is the ratio of the General Parity Index (GPI) in Mali in 2004 to that in 2005?
Make the answer very short. 0.96. What is the ratio of the General Parity Index (GPI) in Samoa in 2004 to that in 2005?
Your response must be concise. 1. What is the ratio of the General Parity Index (GPI) in Afghanistan in 2004 to that in 2006?
Offer a terse response. 0.57. What is the ratio of the General Parity Index (GPI) in Portugal in 2004 to that in 2006?
Your response must be concise. 1.01. What is the ratio of the General Parity Index (GPI) of Samoa in 2004 to that in 2006?
Offer a very short reply. 0.98. What is the ratio of the General Parity Index (GPI) of Afghanistan in 2005 to that in 2006?
Your answer should be compact. 0.9. What is the ratio of the General Parity Index (GPI) in Portugal in 2005 to that in 2006?
Your response must be concise. 1.01. What is the ratio of the General Parity Index (GPI) in Samoa in 2005 to that in 2006?
Provide a short and direct response. 0.98. What is the difference between the highest and the second highest General Parity Index (GPI) of Afghanistan?
Your answer should be compact. 0.01. What is the difference between the highest and the second highest General Parity Index (GPI) of Portugal?
Your response must be concise. 0.01. What is the difference between the highest and the second highest General Parity Index (GPI) in Samoa?
Make the answer very short. 0.08. What is the difference between the highest and the lowest General Parity Index (GPI) in Afghanistan?
Offer a terse response. 0.16. What is the difference between the highest and the lowest General Parity Index (GPI) of Mali?
Your response must be concise. 0.13. What is the difference between the highest and the lowest General Parity Index (GPI) in Portugal?
Your response must be concise. 0.03. What is the difference between the highest and the lowest General Parity Index (GPI) in Samoa?
Make the answer very short. 0.11. 